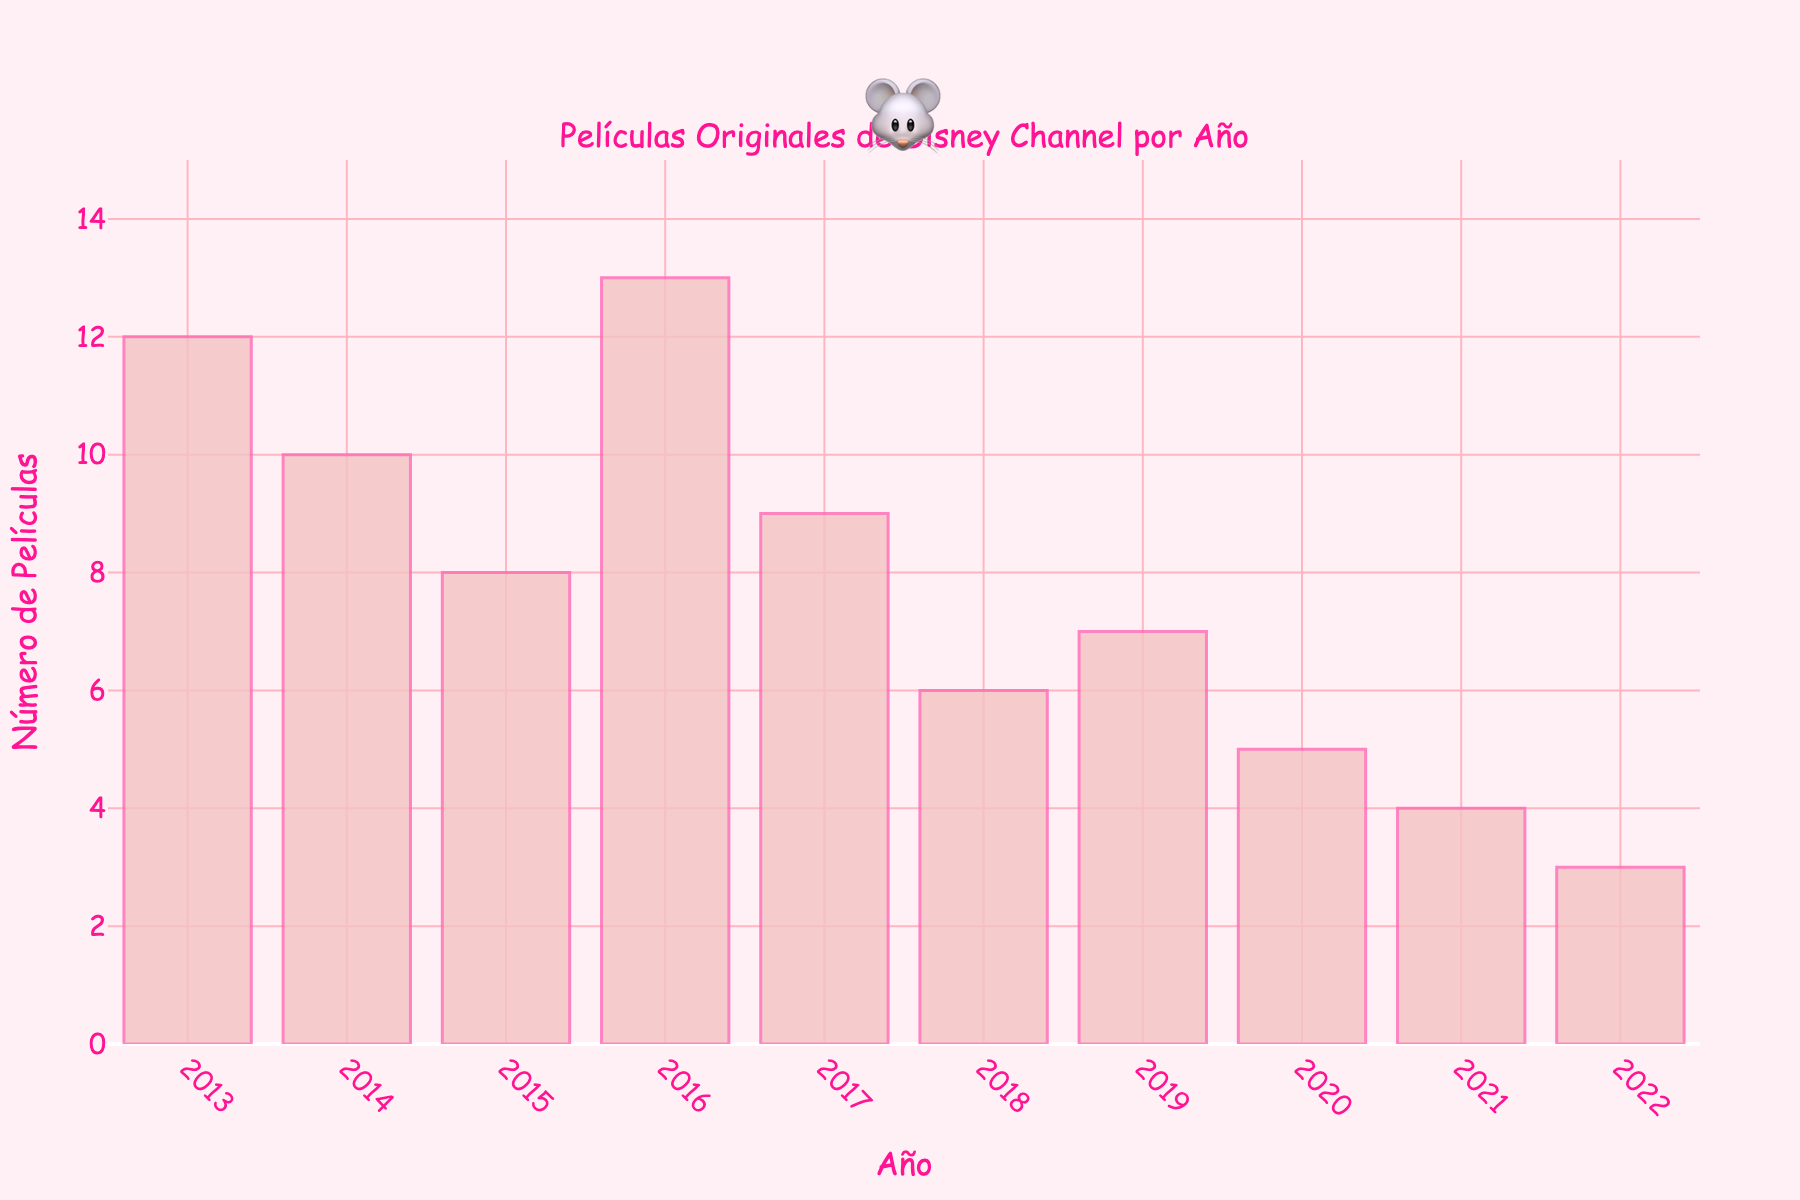Which year had the highest number of Disney Channel original movies released? The year with the highest bar represents the year with the most movies released. In the plot, this is the bar for 2016.
Answer: 2016 What is the total number of movies released from 2013 to 2015? Add the values for the years 2013, 2014, and 2015: 12 (2013) + 10 (2014) + 8 (2015). The total is 12 + 10 + 8 = 30.
Answer: 30 By how much did the number of movies released decrease from 2016 to 2022? Subtract the number for 2022 from the number for 2016: 13 (2016) - 3 (2022). The decrease is 13 - 3 = 10.
Answer: 10 Which year had fewer movies released: 2018 or 2020? Compare the heights of the bars for 2018 and 2020. 2018 has 6 movies and 2020 has 5 movies. 2020 has fewer.
Answer: 2020 What is the average number of movies released per year over the past decade? Sum all the movies released from 2013 to 2022 and divide by 10. (12 + 10 + 8 + 13 + 9 + 6 + 7 + 5 + 4 + 3) / 10 = 77 / 10. The average is 7.7 movies per year.
Answer: 7.7 How many more movies were released in 2013 compared to 2021? Subtract the number of movies released in 2021 from the number released in 2013: 12 (2013) - 4 (2021). The difference is 12 - 4 = 8.
Answer: 8 What was the difference in movies released between the two years with the highest and lowest release numbers? The two years are 2016 with 13 movies and 2022 with 3 movies. Subtract the latter from the former: 13 - 3. The difference is 13 - 3 = 10.
Answer: 10 Did the number of movies released increase or decrease from 2019 to 2020? Compare the bars for 2019 and 2020. 2019 had 7 movies and 2020 had 5 movies, so the number decreased.
Answer: Decrease 